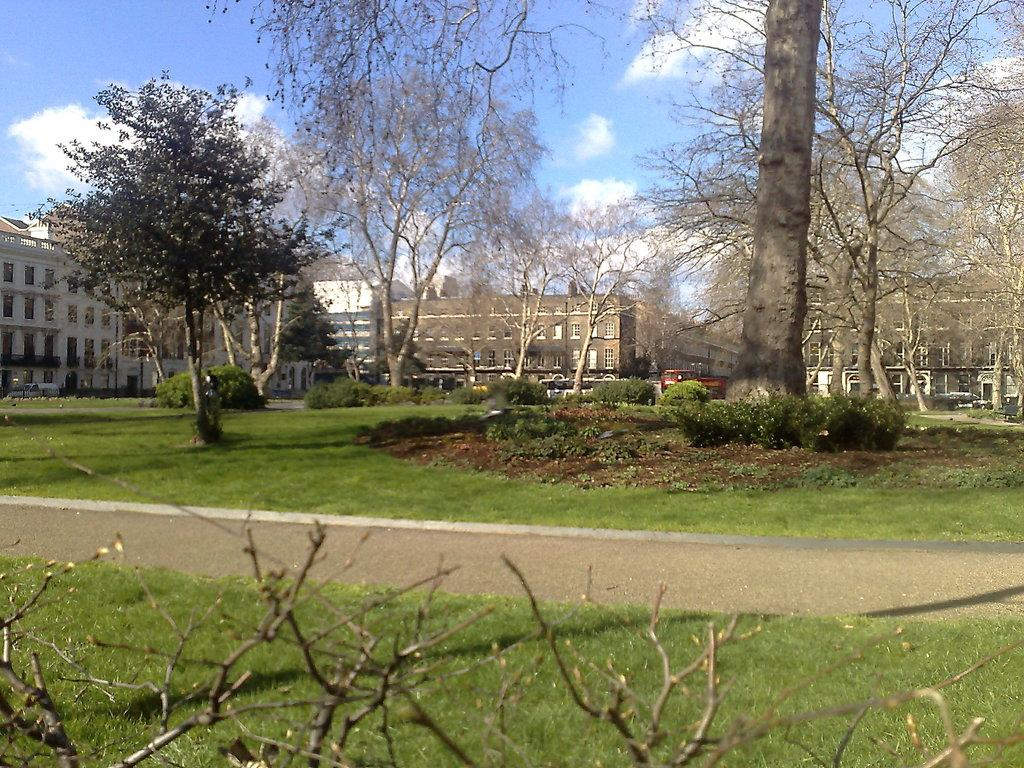What type of vegetation can be seen in the image? There are trees, plants, and grass in the image. What type of man-made structures are present in the image? There are buildings in the image. What type of pathway is visible in the image? There is a road in the image. What is visible in the background of the image? There is a vehicle in the background of the image. What part of the natural environment is visible in the image? The sky is visible in the image, and clouds are present in the sky. What letters are being spelled out by the trees in the image? There are no letters being spelled out by the trees in the image; the trees are simply trees. Who is the uncle in the image? There is no uncle present in the image. 